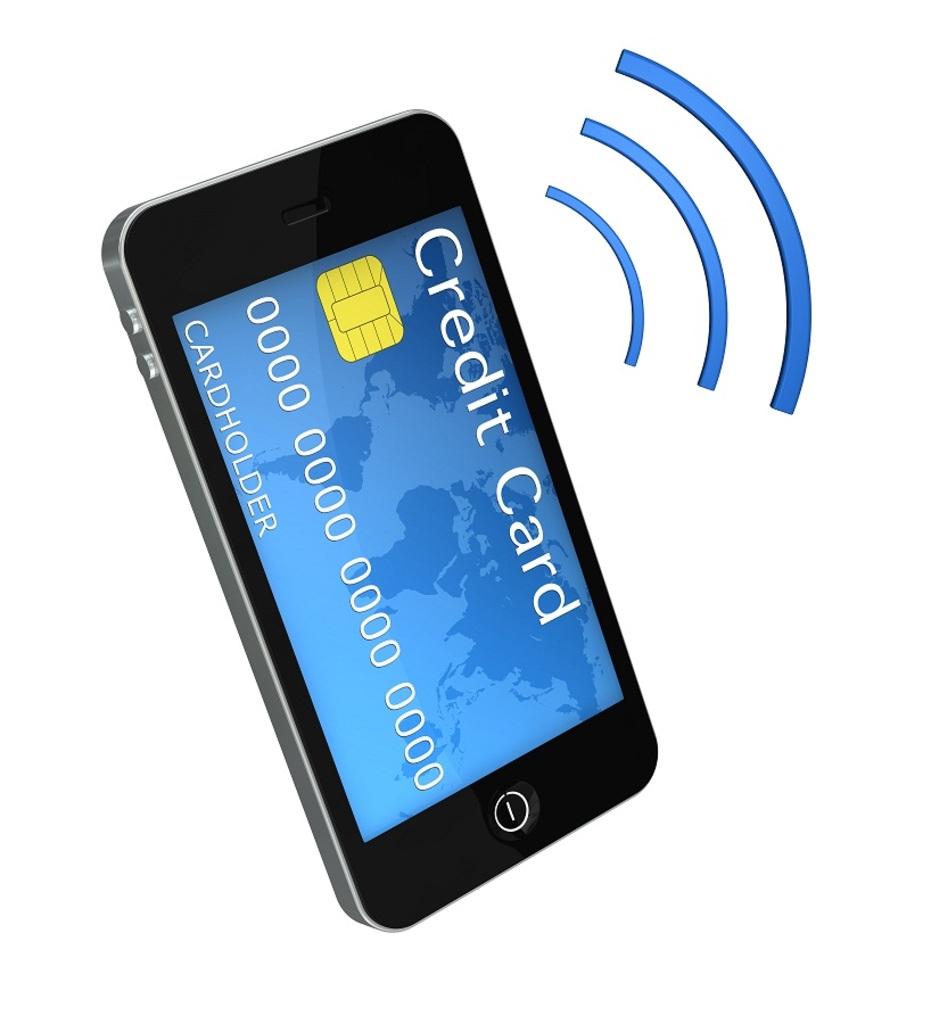What is the card number?
Make the answer very short. 0000 0000 0000 0000. 